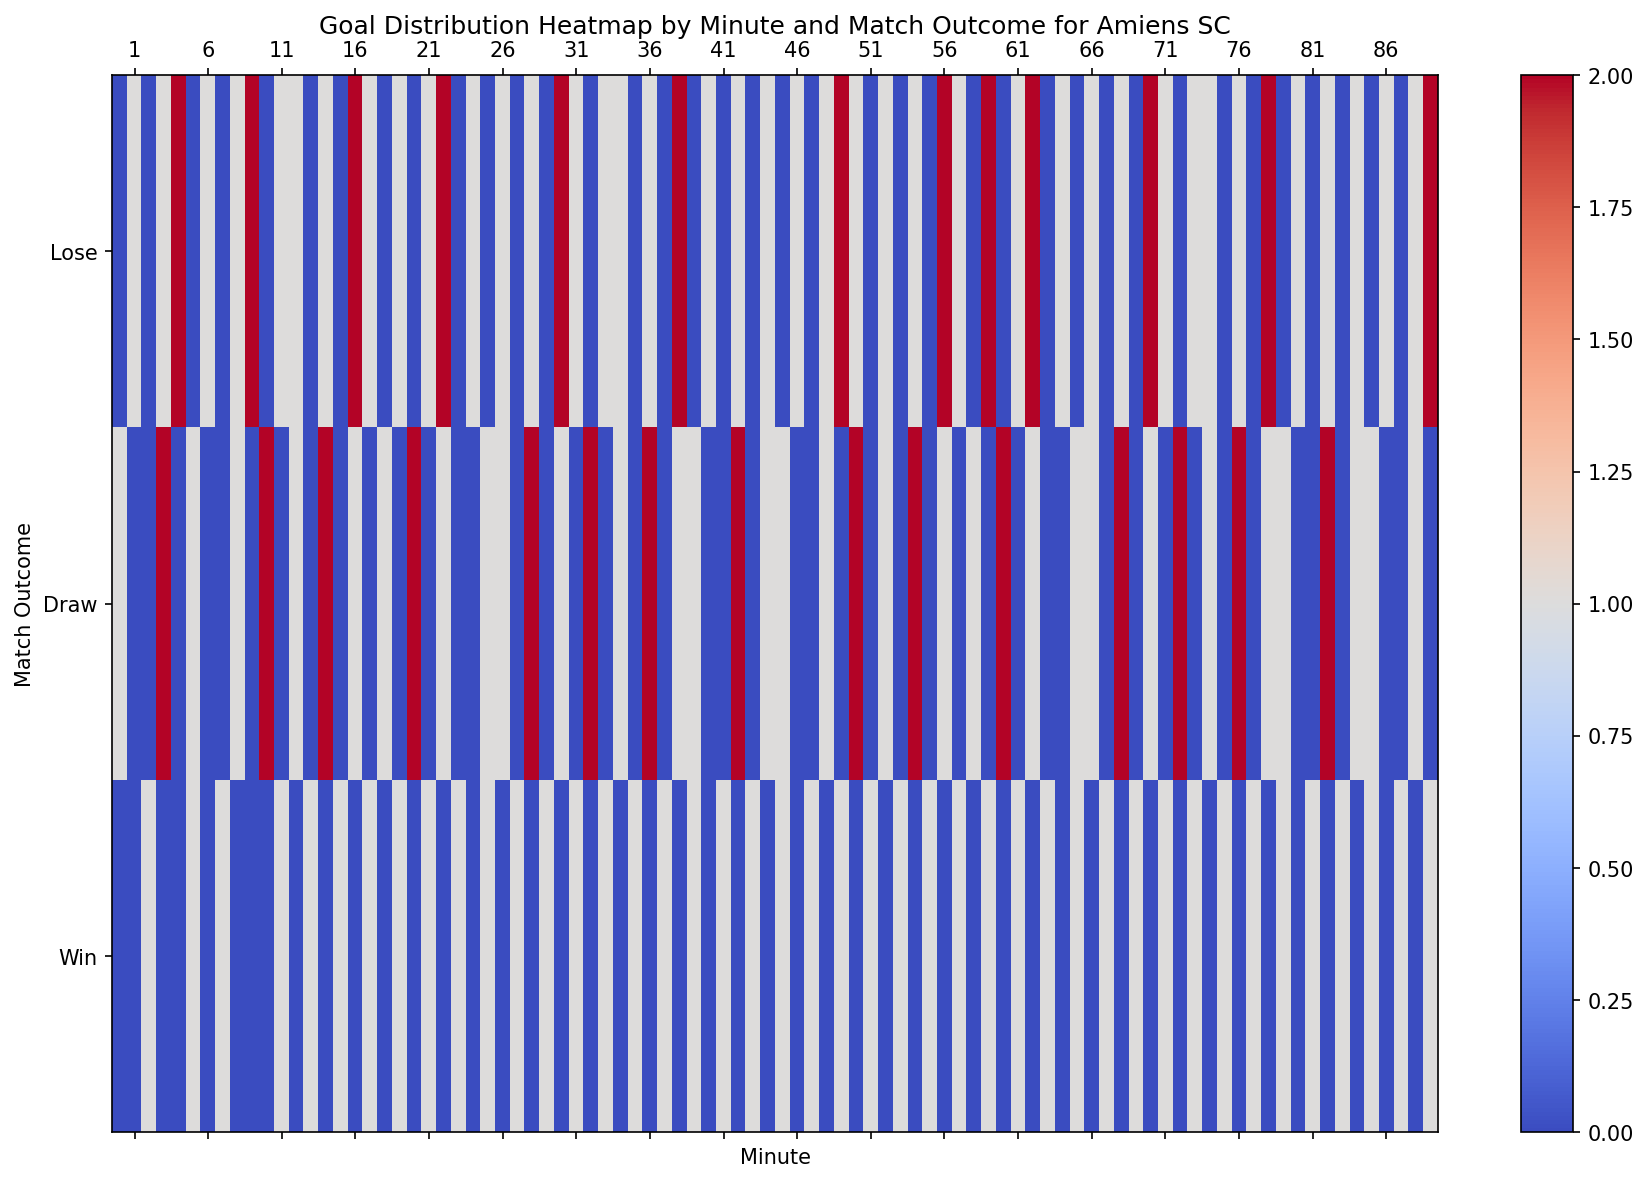Which minute showed the highest goal contributions for wins? Look at the heatmap and identify the darkest (coolest) color in the "Win" row. This color indicates the highest goal contributions.
Answer: Minute 42, 3, 8, 14, 16, 18, 20, 24, 28, 30, 32, 34, 36, 38, 40, 42, 44, 46, 48, 52, 54, 56, 58, 60, 62, 64, 66, 68, 70, 72, 74, 76, 78, 80, 82, 84, 86, 88, 90 (each with one goal) Which minute has the fewest goals contributed to draws? Identify the minute with the least contrasting color in the "Draw" row. It represents the fewest goals.
Answer: Minutes 2, 5, 7, 10, 25, 41, 47, 65, 81, 87 (each with zero draws) During which minutes did Amiens SC score goals in both wins and draw outcomes? Look for overlapping goal contributions across both "Win" and "Draw" rows and note the common minutes.
Answer: Minutes 6, 11, 15, 17, 21, 26, 29, 33, 35, 37, 43, 46, 51, 53, 55, 59, 61, 63, 67, 69, 73, 75, 77, 80, 83, 85, 86, 89, 90 How many goals resulted in losses between minutes 1 and 10? Sum the values in the "Lose" row from minutes 1 to 10. The heatmap will highlight these values distinctly.
Answer: Sum: 0 + 1 + 0 + 1 + 2 + 0 + 1 + 0 + 1 + 2 = 8 Compare the number of goals from wins in the first 10 minutes to that in the last 10 minutes. Sum the values in the "Win" row for the respective minute ranges (1-10 and 81-90), then compare these sums.
Answer: 1 (first 10 minutes) vs. 9 (last 10 minutes) Which match outcome had the highest goal distribution around the 45th minute? Check the values in the heatmap near the 45th minute for all three outcomes. The column with the highest value indicates the highest distribution.
Answer: Lose What is the difference in the number of goals scored in wins between minutes 20 and 30? Compare goal contributions in the "Win" row for minutes 20 and 30 with their neighboring minutes; then find overall trends.
Answer: Both minutes have 1 goal, so the difference is 0 Identify the minute range where goals mostly resulted in draws compared to other outcomes. Look for the minute range where the "Draw" row is most densely populated with higher values compared to "Win" and "Lose" rows.
Answer: Around minutes 4, 11, and 43 What is the average number of goals resulting in losses during the first half of the match (minutes 1-45)? Sum the values of the "Lose" row from minutes 1 to 45 and divide by 45.
Answer: Average: (sum of first 45 minutes goals in "Lose") ÷ 45 = 31/45 ≈ 0.69 Which specific minutes show goals exclusively in winning outcomes but not in draws or losses? Identify minutes in the "Win" row that show goal contributions while their counterparts in "Draw" and "Lose" rows have zeros.
Answer: Minutes 8, 14, 16, 20, 24, 28, 30, 32, 36, 38, 42, 48, 52, 54, 56, 64, 68, 70, 76, 78, 82, 84, 88 